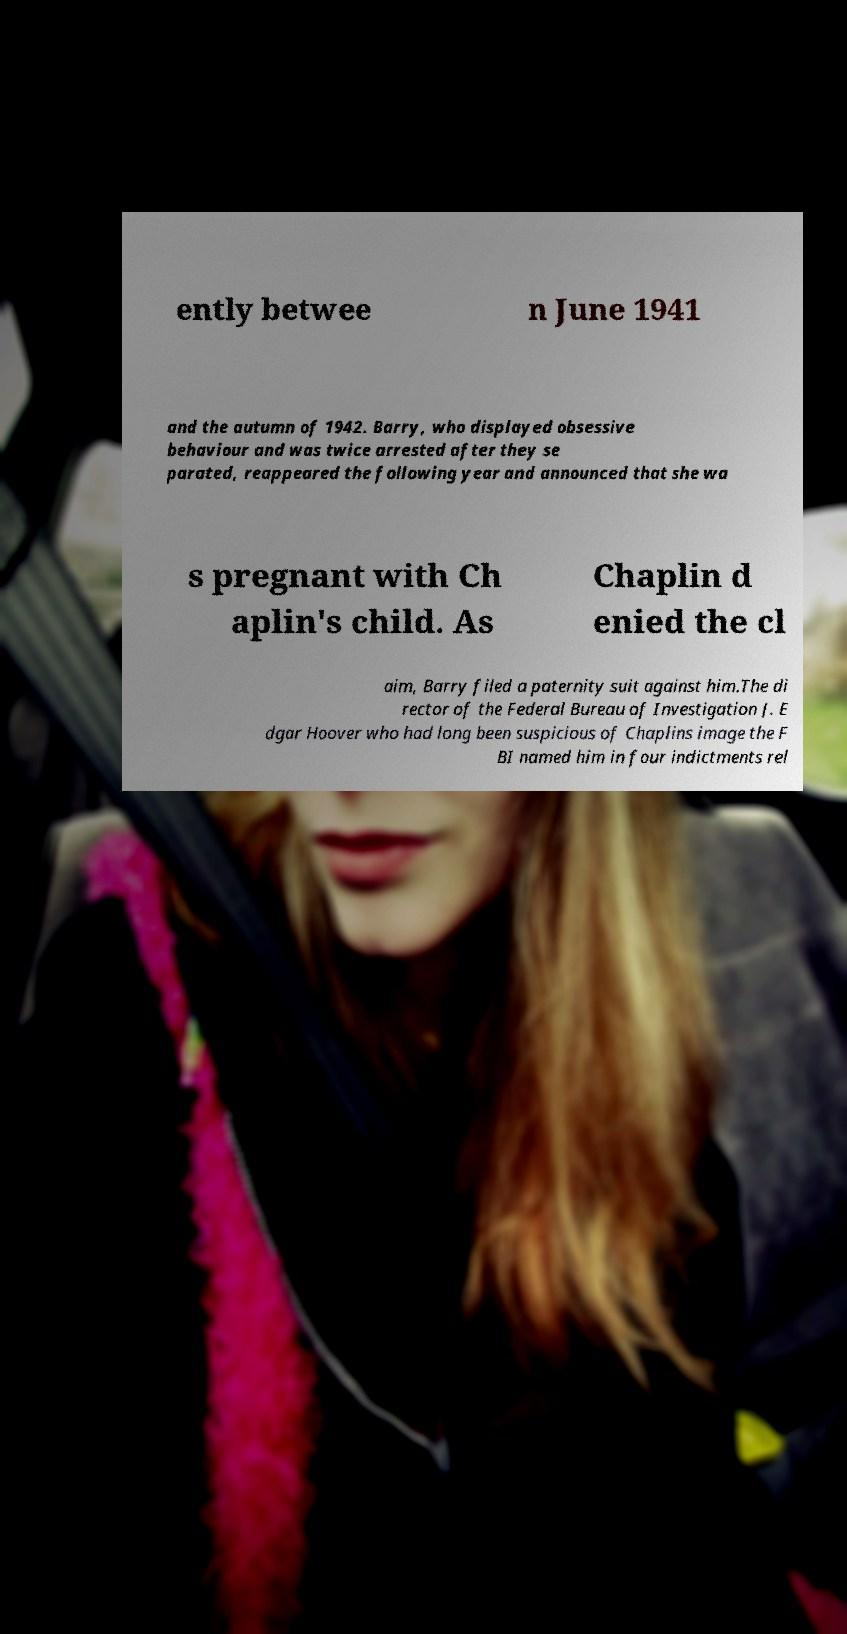I need the written content from this picture converted into text. Can you do that? ently betwee n June 1941 and the autumn of 1942. Barry, who displayed obsessive behaviour and was twice arrested after they se parated, reappeared the following year and announced that she wa s pregnant with Ch aplin's child. As Chaplin d enied the cl aim, Barry filed a paternity suit against him.The di rector of the Federal Bureau of Investigation J. E dgar Hoover who had long been suspicious of Chaplins image the F BI named him in four indictments rel 